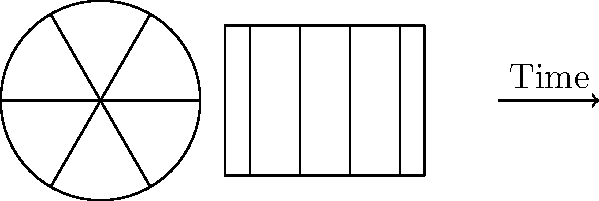In the evolution of cinema, how would you translate the film reel graphic to represent the passage of time from the early days of silent films to the modern digital era? Consider the changes in film technology and storytelling techniques you've witnessed over your career. To represent the passage of time in cinema using the film reel graphic, we can follow these steps:

1. Start with the original film reel on the left side of the graphic, representing early cinema.

2. Translate the film reel to the right, creating multiple instances to show progression:
   a. First translation: Early talkies (1920s-1930s)
   b. Second translation: Color films (1940s-1950s)
   c. Third translation: Widescreen formats (1950s-1960s)
   d. Fourth translation: New Hollywood era (1970s-1980s)
   e. Fifth translation: CGI and digital effects (1990s-2000s)

3. For each translation:
   a. Slightly decrease the size of the film reel to represent the miniaturization of technology.
   b. Adjust the film strip to show relevant changes (e.g., add a soundtrack line for talkies, color for color films).
   c. Modify the number of frames to represent increasing frame rates.

4. For the final translation (representing the digital era):
   a. Replace the film reel with a digital storage icon (e.g., a hard drive or memory card).
   b. Change the film strip to a digital timeline with keyframes.

5. Add labels beneath each translated image to indicate the era or significant technological advancement.

6. Draw arrows between each translation to show the progression of time.

This representation would visually depict the evolution of cinema technology and storytelling techniques from the early silent film era to the modern digital age, reflecting the changes an experienced actress would have witnessed throughout her career.
Answer: Translate film reel right, decreasing size; modify strip for tech changes; end with digital icon. 